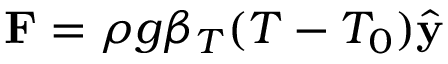Convert formula to latex. <formula><loc_0><loc_0><loc_500><loc_500>F = \rho g \beta _ { T } ( T - T _ { 0 } ) \hat { y }</formula> 